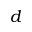<formula> <loc_0><loc_0><loc_500><loc_500>d</formula> 